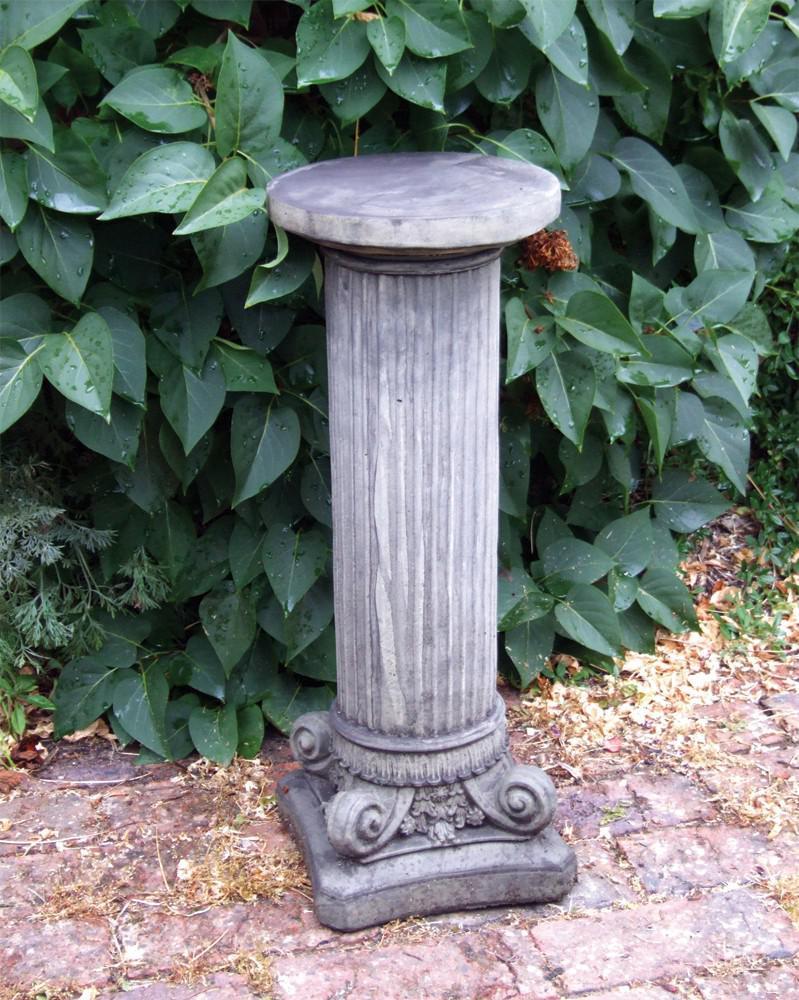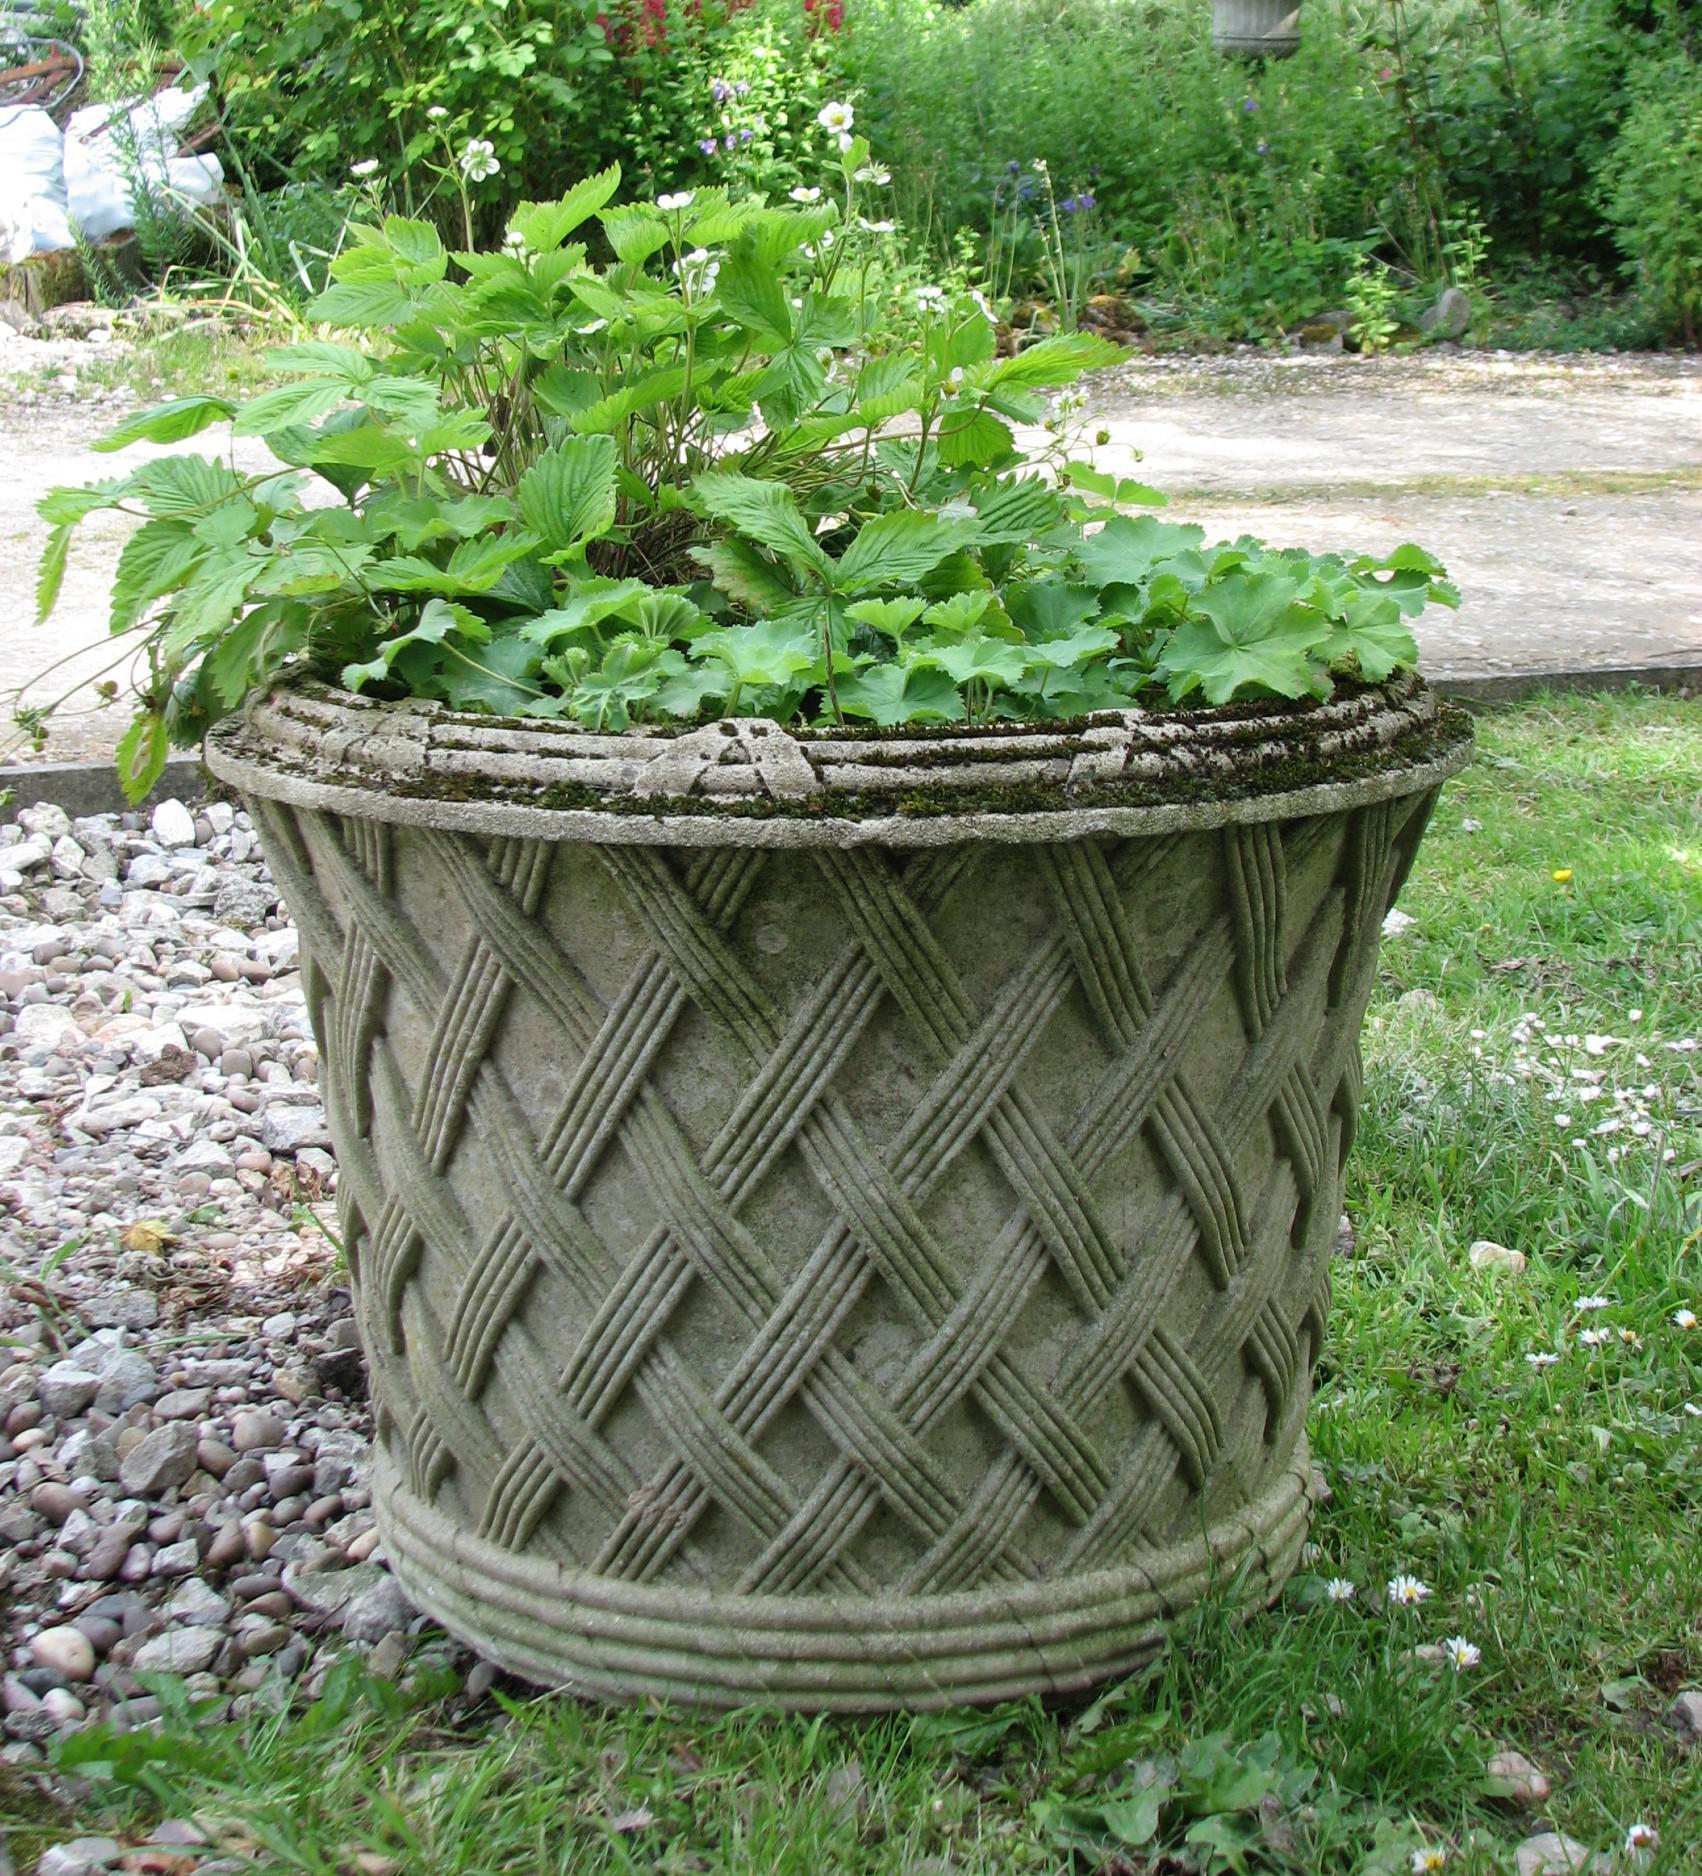The first image is the image on the left, the second image is the image on the right. Considering the images on both sides, is "There are no flowers on the pedestal on the left." valid? Answer yes or no. Yes. 